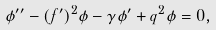Convert formula to latex. <formula><loc_0><loc_0><loc_500><loc_500>\phi ^ { \prime \prime } - ( f ^ { \prime } ) ^ { 2 } \phi - \gamma \phi ^ { \prime } + q ^ { 2 } \phi = 0 ,</formula> 